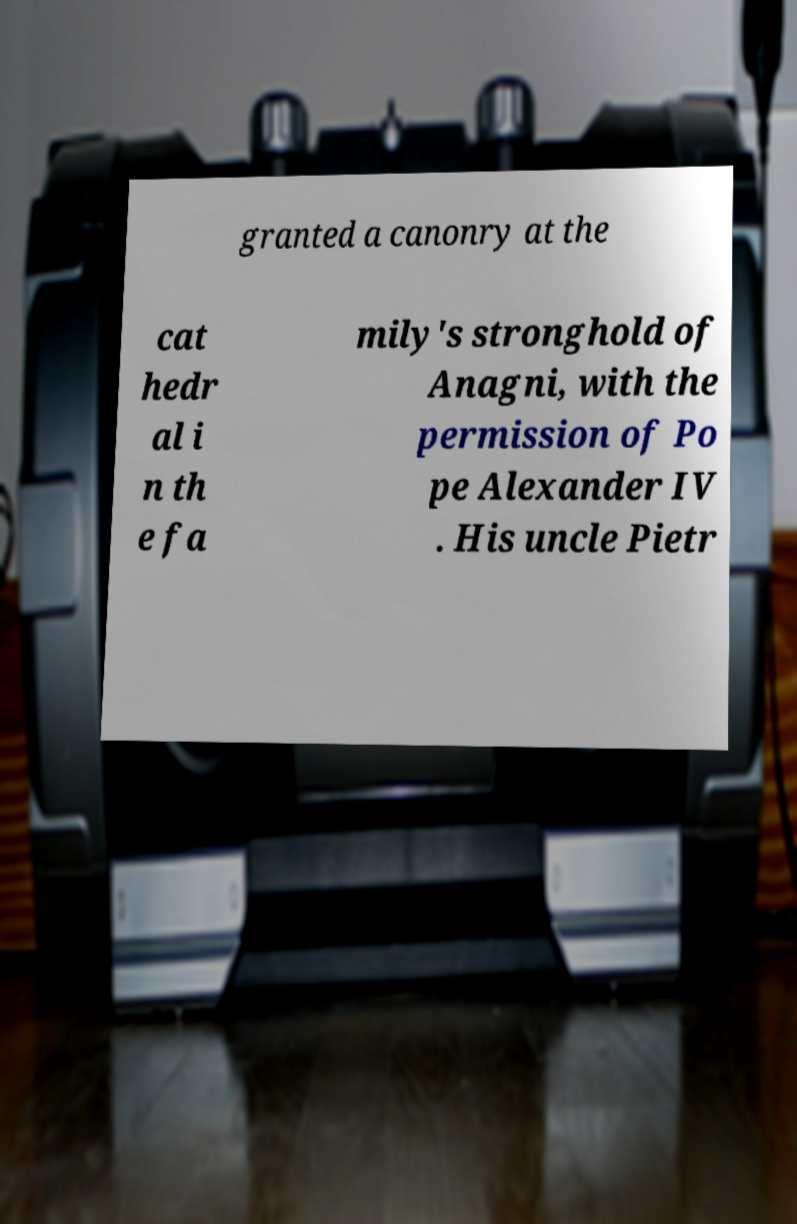Could you extract and type out the text from this image? granted a canonry at the cat hedr al i n th e fa mily's stronghold of Anagni, with the permission of Po pe Alexander IV . His uncle Pietr 